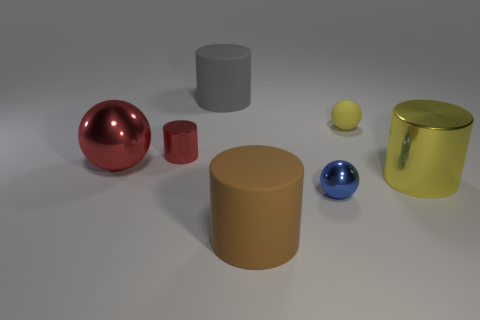There is a object that is the same color as the large shiny cylinder; what is it made of?
Ensure brevity in your answer.  Rubber. How many objects are on the right side of the tiny blue object and behind the big ball?
Offer a very short reply. 1. Are there fewer red shiny things that are behind the small yellow sphere than large brown matte objects?
Give a very brief answer. Yes. There is a gray object that is the same size as the yellow shiny cylinder; what shape is it?
Give a very brief answer. Cylinder. How many other objects are the same color as the tiny rubber sphere?
Make the answer very short. 1. Is the yellow ball the same size as the yellow cylinder?
Provide a short and direct response. No. What number of things are small yellow matte things or small balls behind the tiny red cylinder?
Your answer should be compact. 1. Are there fewer tiny red cylinders that are on the right side of the gray rubber cylinder than yellow cylinders that are to the left of the big brown cylinder?
Keep it short and to the point. No. What number of other objects are the same material as the large brown thing?
Make the answer very short. 2. Is the color of the big metal thing behind the large yellow metallic object the same as the small cylinder?
Give a very brief answer. Yes. 